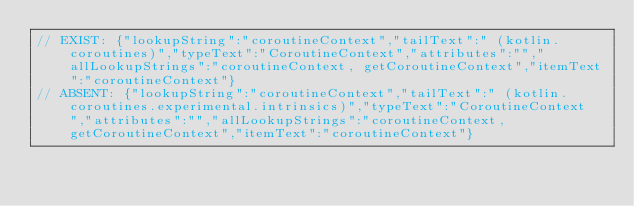<code> <loc_0><loc_0><loc_500><loc_500><_Kotlin_>// EXIST: {"lookupString":"coroutineContext","tailText":" (kotlin.coroutines)","typeText":"CoroutineContext","attributes":"","allLookupStrings":"coroutineContext, getCoroutineContext","itemText":"coroutineContext"}
// ABSENT: {"lookupString":"coroutineContext","tailText":" (kotlin.coroutines.experimental.intrinsics)","typeText":"CoroutineContext","attributes":"","allLookupStrings":"coroutineContext, getCoroutineContext","itemText":"coroutineContext"}
</code> 